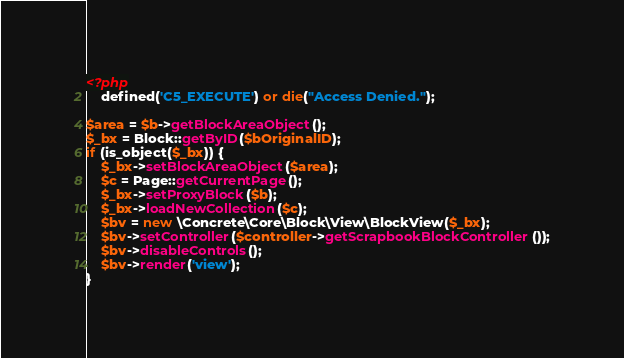Convert code to text. <code><loc_0><loc_0><loc_500><loc_500><_PHP_><?php
	defined('C5_EXECUTE') or die("Access Denied.");

$area = $b->getBlockAreaObject();
$_bx = Block::getByID($bOriginalID);
if (is_object($_bx)) {
	$_bx->setBlockAreaObject($area);
	$c = Page::getCurrentPage();
	$_bx->setProxyBlock($b);
	$_bx->loadNewCollection($c);
    $bv = new \Concrete\Core\Block\View\BlockView($_bx);
	$bv->setController($controller->getScrapbookBlockController());
    $bv->disableControls();
    $bv->render('view');
}</code> 